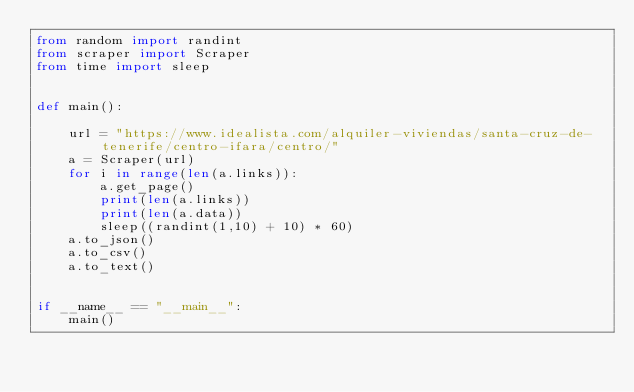<code> <loc_0><loc_0><loc_500><loc_500><_Python_>from random import randint
from scraper import Scraper
from time import sleep


def main():

    url = "https://www.idealista.com/alquiler-viviendas/santa-cruz-de-tenerife/centro-ifara/centro/"
    a = Scraper(url)
    for i in range(len(a.links)):
        a.get_page()
        print(len(a.links))
        print(len(a.data))
        sleep((randint(1,10) + 10) * 60)
    a.to_json()
    a.to_csv()
    a.to_text()


if __name__ == "__main__":
    main()</code> 